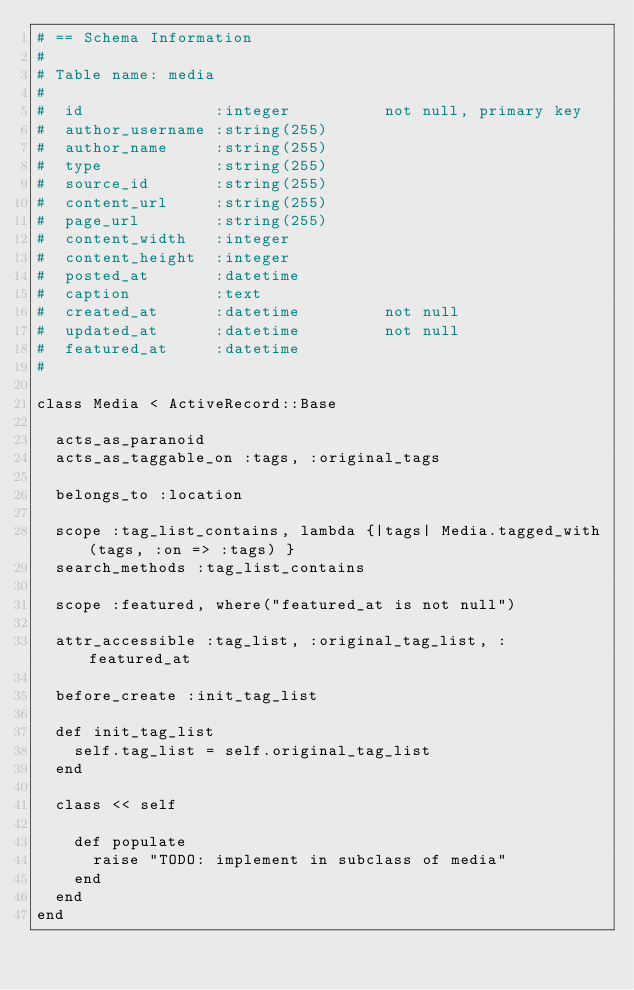<code> <loc_0><loc_0><loc_500><loc_500><_Ruby_># == Schema Information
#
# Table name: media
#
#  id              :integer          not null, primary key
#  author_username :string(255)
#  author_name     :string(255)
#  type            :string(255)
#  source_id       :string(255)
#  content_url     :string(255)
#  page_url        :string(255)
#  content_width   :integer
#  content_height  :integer
#  posted_at       :datetime
#  caption         :text
#  created_at      :datetime         not null
#  updated_at      :datetime         not null
#  featured_at     :datetime
#

class Media < ActiveRecord::Base
 
  acts_as_paranoid
  acts_as_taggable_on :tags, :original_tags
  
  belongs_to :location
  
  scope :tag_list_contains, lambda {|tags| Media.tagged_with(tags, :on => :tags) }
  search_methods :tag_list_contains
  
  scope :featured, where("featured_at is not null")
  
  attr_accessible :tag_list, :original_tag_list, :featured_at
  
  before_create :init_tag_list
  
  def init_tag_list
    self.tag_list = self.original_tag_list
  end
 
  class << self
    
    def populate
      raise "TODO: implement in subclass of media"
    end
  end
end
</code> 